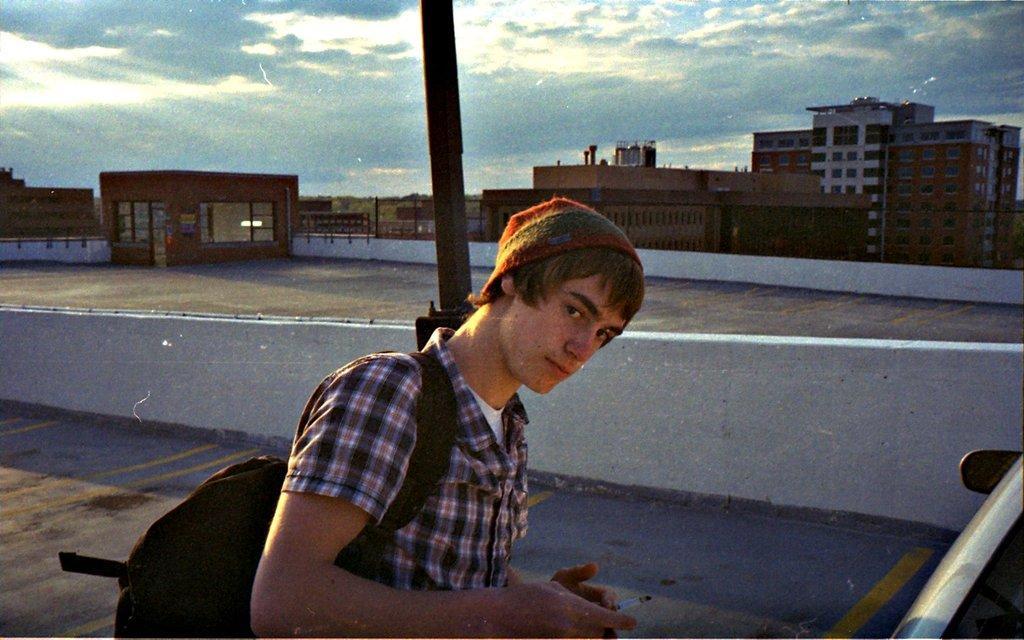In one or two sentences, can you explain what this image depicts? This image consists of a man wearing a bag. He is also wearing a cap. At the bottom, there is a road. In the background, there are buildings. At the top, there are clouds in the sky. Behind him, there is a pole. 